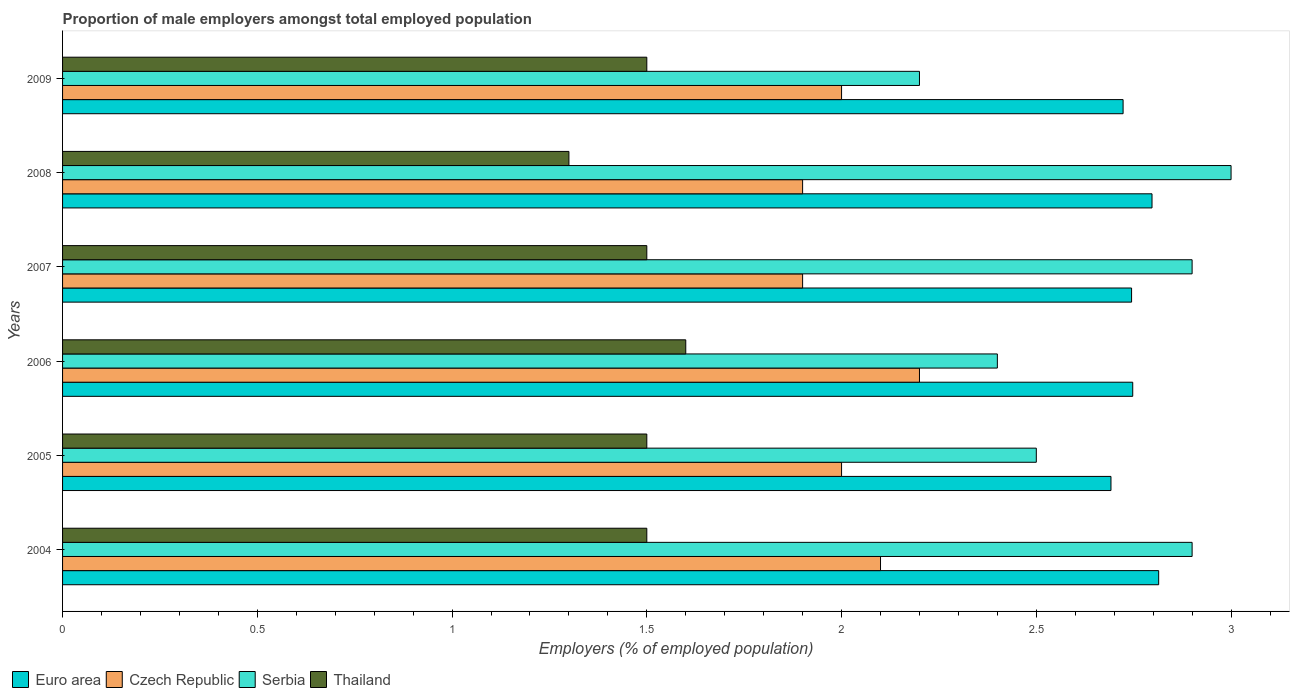How many different coloured bars are there?
Keep it short and to the point. 4. How many groups of bars are there?
Keep it short and to the point. 6. Are the number of bars per tick equal to the number of legend labels?
Offer a terse response. Yes. How many bars are there on the 4th tick from the top?
Ensure brevity in your answer.  4. What is the label of the 4th group of bars from the top?
Offer a very short reply. 2006. In how many cases, is the number of bars for a given year not equal to the number of legend labels?
Ensure brevity in your answer.  0. What is the proportion of male employers in Serbia in 2007?
Ensure brevity in your answer.  2.9. Across all years, what is the maximum proportion of male employers in Czech Republic?
Provide a succinct answer. 2.2. Across all years, what is the minimum proportion of male employers in Serbia?
Provide a succinct answer. 2.2. In which year was the proportion of male employers in Czech Republic maximum?
Make the answer very short. 2006. In which year was the proportion of male employers in Czech Republic minimum?
Keep it short and to the point. 2007. What is the total proportion of male employers in Euro area in the graph?
Provide a succinct answer. 16.52. What is the difference between the proportion of male employers in Serbia in 2006 and that in 2007?
Keep it short and to the point. -0.5. What is the difference between the proportion of male employers in Serbia in 2004 and the proportion of male employers in Thailand in 2008?
Give a very brief answer. 1.6. What is the average proportion of male employers in Czech Republic per year?
Offer a very short reply. 2.02. In the year 2008, what is the difference between the proportion of male employers in Thailand and proportion of male employers in Czech Republic?
Your response must be concise. -0.6. In how many years, is the proportion of male employers in Euro area greater than 2.7 %?
Provide a short and direct response. 5. What is the ratio of the proportion of male employers in Euro area in 2005 to that in 2007?
Keep it short and to the point. 0.98. What is the difference between the highest and the second highest proportion of male employers in Euro area?
Offer a very short reply. 0.02. What is the difference between the highest and the lowest proportion of male employers in Thailand?
Your answer should be very brief. 0.3. In how many years, is the proportion of male employers in Serbia greater than the average proportion of male employers in Serbia taken over all years?
Keep it short and to the point. 3. Is the sum of the proportion of male employers in Czech Republic in 2004 and 2009 greater than the maximum proportion of male employers in Serbia across all years?
Offer a very short reply. Yes. Is it the case that in every year, the sum of the proportion of male employers in Czech Republic and proportion of male employers in Euro area is greater than the sum of proportion of male employers in Serbia and proportion of male employers in Thailand?
Your response must be concise. Yes. What does the 3rd bar from the top in 2009 represents?
Keep it short and to the point. Czech Republic. What does the 3rd bar from the bottom in 2006 represents?
Your answer should be very brief. Serbia. How many bars are there?
Your response must be concise. 24. How many years are there in the graph?
Keep it short and to the point. 6. Does the graph contain any zero values?
Your answer should be very brief. No. Where does the legend appear in the graph?
Offer a very short reply. Bottom left. How are the legend labels stacked?
Provide a succinct answer. Horizontal. What is the title of the graph?
Provide a succinct answer. Proportion of male employers amongst total employed population. Does "High income" appear as one of the legend labels in the graph?
Offer a terse response. No. What is the label or title of the X-axis?
Provide a short and direct response. Employers (% of employed population). What is the label or title of the Y-axis?
Ensure brevity in your answer.  Years. What is the Employers (% of employed population) in Euro area in 2004?
Your response must be concise. 2.81. What is the Employers (% of employed population) of Czech Republic in 2004?
Your answer should be very brief. 2.1. What is the Employers (% of employed population) of Serbia in 2004?
Your answer should be very brief. 2.9. What is the Employers (% of employed population) in Thailand in 2004?
Provide a succinct answer. 1.5. What is the Employers (% of employed population) in Euro area in 2005?
Your response must be concise. 2.69. What is the Employers (% of employed population) in Czech Republic in 2005?
Keep it short and to the point. 2. What is the Employers (% of employed population) in Thailand in 2005?
Ensure brevity in your answer.  1.5. What is the Employers (% of employed population) of Euro area in 2006?
Make the answer very short. 2.75. What is the Employers (% of employed population) in Czech Republic in 2006?
Your response must be concise. 2.2. What is the Employers (% of employed population) of Serbia in 2006?
Your response must be concise. 2.4. What is the Employers (% of employed population) in Thailand in 2006?
Make the answer very short. 1.6. What is the Employers (% of employed population) of Euro area in 2007?
Ensure brevity in your answer.  2.74. What is the Employers (% of employed population) of Czech Republic in 2007?
Your answer should be compact. 1.9. What is the Employers (% of employed population) in Serbia in 2007?
Provide a short and direct response. 2.9. What is the Employers (% of employed population) of Thailand in 2007?
Your answer should be compact. 1.5. What is the Employers (% of employed population) in Euro area in 2008?
Your answer should be compact. 2.8. What is the Employers (% of employed population) in Czech Republic in 2008?
Offer a terse response. 1.9. What is the Employers (% of employed population) of Thailand in 2008?
Your answer should be very brief. 1.3. What is the Employers (% of employed population) of Euro area in 2009?
Provide a succinct answer. 2.72. What is the Employers (% of employed population) of Serbia in 2009?
Keep it short and to the point. 2.2. What is the Employers (% of employed population) in Thailand in 2009?
Offer a terse response. 1.5. Across all years, what is the maximum Employers (% of employed population) in Euro area?
Provide a short and direct response. 2.81. Across all years, what is the maximum Employers (% of employed population) in Czech Republic?
Offer a terse response. 2.2. Across all years, what is the maximum Employers (% of employed population) in Serbia?
Your answer should be very brief. 3. Across all years, what is the maximum Employers (% of employed population) of Thailand?
Give a very brief answer. 1.6. Across all years, what is the minimum Employers (% of employed population) of Euro area?
Provide a succinct answer. 2.69. Across all years, what is the minimum Employers (% of employed population) in Czech Republic?
Provide a short and direct response. 1.9. Across all years, what is the minimum Employers (% of employed population) of Serbia?
Your answer should be compact. 2.2. Across all years, what is the minimum Employers (% of employed population) in Thailand?
Provide a short and direct response. 1.3. What is the total Employers (% of employed population) in Euro area in the graph?
Your response must be concise. 16.52. What is the total Employers (% of employed population) of Serbia in the graph?
Provide a succinct answer. 15.9. What is the difference between the Employers (% of employed population) in Euro area in 2004 and that in 2005?
Ensure brevity in your answer.  0.12. What is the difference between the Employers (% of employed population) of Thailand in 2004 and that in 2005?
Offer a terse response. 0. What is the difference between the Employers (% of employed population) of Euro area in 2004 and that in 2006?
Make the answer very short. 0.07. What is the difference between the Employers (% of employed population) of Serbia in 2004 and that in 2006?
Your answer should be compact. 0.5. What is the difference between the Employers (% of employed population) of Euro area in 2004 and that in 2007?
Your response must be concise. 0.07. What is the difference between the Employers (% of employed population) in Thailand in 2004 and that in 2007?
Give a very brief answer. 0. What is the difference between the Employers (% of employed population) in Euro area in 2004 and that in 2008?
Provide a succinct answer. 0.02. What is the difference between the Employers (% of employed population) in Czech Republic in 2004 and that in 2008?
Provide a short and direct response. 0.2. What is the difference between the Employers (% of employed population) of Serbia in 2004 and that in 2008?
Offer a very short reply. -0.1. What is the difference between the Employers (% of employed population) in Euro area in 2004 and that in 2009?
Give a very brief answer. 0.09. What is the difference between the Employers (% of employed population) of Czech Republic in 2004 and that in 2009?
Offer a terse response. 0.1. What is the difference between the Employers (% of employed population) of Serbia in 2004 and that in 2009?
Your answer should be compact. 0.7. What is the difference between the Employers (% of employed population) in Thailand in 2004 and that in 2009?
Provide a short and direct response. 0. What is the difference between the Employers (% of employed population) of Euro area in 2005 and that in 2006?
Provide a short and direct response. -0.06. What is the difference between the Employers (% of employed population) of Serbia in 2005 and that in 2006?
Your answer should be very brief. 0.1. What is the difference between the Employers (% of employed population) of Thailand in 2005 and that in 2006?
Ensure brevity in your answer.  -0.1. What is the difference between the Employers (% of employed population) in Euro area in 2005 and that in 2007?
Offer a very short reply. -0.05. What is the difference between the Employers (% of employed population) in Czech Republic in 2005 and that in 2007?
Provide a short and direct response. 0.1. What is the difference between the Employers (% of employed population) in Thailand in 2005 and that in 2007?
Keep it short and to the point. 0. What is the difference between the Employers (% of employed population) in Euro area in 2005 and that in 2008?
Your response must be concise. -0.11. What is the difference between the Employers (% of employed population) of Czech Republic in 2005 and that in 2008?
Ensure brevity in your answer.  0.1. What is the difference between the Employers (% of employed population) in Thailand in 2005 and that in 2008?
Offer a terse response. 0.2. What is the difference between the Employers (% of employed population) of Euro area in 2005 and that in 2009?
Your answer should be very brief. -0.03. What is the difference between the Employers (% of employed population) of Czech Republic in 2005 and that in 2009?
Offer a terse response. 0. What is the difference between the Employers (% of employed population) of Serbia in 2005 and that in 2009?
Make the answer very short. 0.3. What is the difference between the Employers (% of employed population) in Thailand in 2005 and that in 2009?
Your response must be concise. 0. What is the difference between the Employers (% of employed population) in Euro area in 2006 and that in 2007?
Your answer should be compact. 0. What is the difference between the Employers (% of employed population) of Euro area in 2006 and that in 2008?
Ensure brevity in your answer.  -0.05. What is the difference between the Employers (% of employed population) in Czech Republic in 2006 and that in 2008?
Your answer should be very brief. 0.3. What is the difference between the Employers (% of employed population) of Euro area in 2006 and that in 2009?
Your answer should be very brief. 0.02. What is the difference between the Employers (% of employed population) of Serbia in 2006 and that in 2009?
Offer a very short reply. 0.2. What is the difference between the Employers (% of employed population) in Thailand in 2006 and that in 2009?
Provide a short and direct response. 0.1. What is the difference between the Employers (% of employed population) of Euro area in 2007 and that in 2008?
Your answer should be compact. -0.05. What is the difference between the Employers (% of employed population) in Euro area in 2007 and that in 2009?
Your answer should be compact. 0.02. What is the difference between the Employers (% of employed population) in Serbia in 2007 and that in 2009?
Offer a very short reply. 0.7. What is the difference between the Employers (% of employed population) of Euro area in 2008 and that in 2009?
Your answer should be compact. 0.07. What is the difference between the Employers (% of employed population) of Czech Republic in 2008 and that in 2009?
Offer a very short reply. -0.1. What is the difference between the Employers (% of employed population) of Serbia in 2008 and that in 2009?
Offer a terse response. 0.8. What is the difference between the Employers (% of employed population) in Euro area in 2004 and the Employers (% of employed population) in Czech Republic in 2005?
Your answer should be very brief. 0.81. What is the difference between the Employers (% of employed population) in Euro area in 2004 and the Employers (% of employed population) in Serbia in 2005?
Offer a terse response. 0.31. What is the difference between the Employers (% of employed population) of Euro area in 2004 and the Employers (% of employed population) of Thailand in 2005?
Make the answer very short. 1.31. What is the difference between the Employers (% of employed population) of Czech Republic in 2004 and the Employers (% of employed population) of Serbia in 2005?
Provide a succinct answer. -0.4. What is the difference between the Employers (% of employed population) of Czech Republic in 2004 and the Employers (% of employed population) of Thailand in 2005?
Your answer should be compact. 0.6. What is the difference between the Employers (% of employed population) of Serbia in 2004 and the Employers (% of employed population) of Thailand in 2005?
Give a very brief answer. 1.4. What is the difference between the Employers (% of employed population) of Euro area in 2004 and the Employers (% of employed population) of Czech Republic in 2006?
Your response must be concise. 0.61. What is the difference between the Employers (% of employed population) of Euro area in 2004 and the Employers (% of employed population) of Serbia in 2006?
Offer a very short reply. 0.41. What is the difference between the Employers (% of employed population) of Euro area in 2004 and the Employers (% of employed population) of Thailand in 2006?
Your answer should be very brief. 1.21. What is the difference between the Employers (% of employed population) of Serbia in 2004 and the Employers (% of employed population) of Thailand in 2006?
Provide a short and direct response. 1.3. What is the difference between the Employers (% of employed population) in Euro area in 2004 and the Employers (% of employed population) in Czech Republic in 2007?
Your answer should be very brief. 0.91. What is the difference between the Employers (% of employed population) of Euro area in 2004 and the Employers (% of employed population) of Serbia in 2007?
Offer a terse response. -0.09. What is the difference between the Employers (% of employed population) of Euro area in 2004 and the Employers (% of employed population) of Thailand in 2007?
Keep it short and to the point. 1.31. What is the difference between the Employers (% of employed population) of Czech Republic in 2004 and the Employers (% of employed population) of Thailand in 2007?
Your answer should be compact. 0.6. What is the difference between the Employers (% of employed population) in Euro area in 2004 and the Employers (% of employed population) in Czech Republic in 2008?
Your answer should be compact. 0.91. What is the difference between the Employers (% of employed population) in Euro area in 2004 and the Employers (% of employed population) in Serbia in 2008?
Offer a terse response. -0.19. What is the difference between the Employers (% of employed population) in Euro area in 2004 and the Employers (% of employed population) in Thailand in 2008?
Make the answer very short. 1.51. What is the difference between the Employers (% of employed population) in Czech Republic in 2004 and the Employers (% of employed population) in Serbia in 2008?
Offer a terse response. -0.9. What is the difference between the Employers (% of employed population) of Euro area in 2004 and the Employers (% of employed population) of Czech Republic in 2009?
Provide a succinct answer. 0.81. What is the difference between the Employers (% of employed population) in Euro area in 2004 and the Employers (% of employed population) in Serbia in 2009?
Your answer should be very brief. 0.61. What is the difference between the Employers (% of employed population) of Euro area in 2004 and the Employers (% of employed population) of Thailand in 2009?
Your response must be concise. 1.31. What is the difference between the Employers (% of employed population) in Czech Republic in 2004 and the Employers (% of employed population) in Serbia in 2009?
Your answer should be compact. -0.1. What is the difference between the Employers (% of employed population) of Czech Republic in 2004 and the Employers (% of employed population) of Thailand in 2009?
Offer a terse response. 0.6. What is the difference between the Employers (% of employed population) in Euro area in 2005 and the Employers (% of employed population) in Czech Republic in 2006?
Make the answer very short. 0.49. What is the difference between the Employers (% of employed population) in Euro area in 2005 and the Employers (% of employed population) in Serbia in 2006?
Your response must be concise. 0.29. What is the difference between the Employers (% of employed population) in Euro area in 2005 and the Employers (% of employed population) in Thailand in 2006?
Offer a very short reply. 1.09. What is the difference between the Employers (% of employed population) of Czech Republic in 2005 and the Employers (% of employed population) of Thailand in 2006?
Keep it short and to the point. 0.4. What is the difference between the Employers (% of employed population) in Serbia in 2005 and the Employers (% of employed population) in Thailand in 2006?
Keep it short and to the point. 0.9. What is the difference between the Employers (% of employed population) in Euro area in 2005 and the Employers (% of employed population) in Czech Republic in 2007?
Ensure brevity in your answer.  0.79. What is the difference between the Employers (% of employed population) of Euro area in 2005 and the Employers (% of employed population) of Serbia in 2007?
Make the answer very short. -0.21. What is the difference between the Employers (% of employed population) in Euro area in 2005 and the Employers (% of employed population) in Thailand in 2007?
Your response must be concise. 1.19. What is the difference between the Employers (% of employed population) of Czech Republic in 2005 and the Employers (% of employed population) of Serbia in 2007?
Your answer should be very brief. -0.9. What is the difference between the Employers (% of employed population) in Czech Republic in 2005 and the Employers (% of employed population) in Thailand in 2007?
Give a very brief answer. 0.5. What is the difference between the Employers (% of employed population) in Serbia in 2005 and the Employers (% of employed population) in Thailand in 2007?
Your answer should be compact. 1. What is the difference between the Employers (% of employed population) in Euro area in 2005 and the Employers (% of employed population) in Czech Republic in 2008?
Your answer should be compact. 0.79. What is the difference between the Employers (% of employed population) of Euro area in 2005 and the Employers (% of employed population) of Serbia in 2008?
Ensure brevity in your answer.  -0.31. What is the difference between the Employers (% of employed population) of Euro area in 2005 and the Employers (% of employed population) of Thailand in 2008?
Your answer should be compact. 1.39. What is the difference between the Employers (% of employed population) in Czech Republic in 2005 and the Employers (% of employed population) in Serbia in 2008?
Provide a short and direct response. -1. What is the difference between the Employers (% of employed population) of Czech Republic in 2005 and the Employers (% of employed population) of Thailand in 2008?
Your answer should be very brief. 0.7. What is the difference between the Employers (% of employed population) of Serbia in 2005 and the Employers (% of employed population) of Thailand in 2008?
Provide a short and direct response. 1.2. What is the difference between the Employers (% of employed population) of Euro area in 2005 and the Employers (% of employed population) of Czech Republic in 2009?
Your response must be concise. 0.69. What is the difference between the Employers (% of employed population) in Euro area in 2005 and the Employers (% of employed population) in Serbia in 2009?
Offer a very short reply. 0.49. What is the difference between the Employers (% of employed population) of Euro area in 2005 and the Employers (% of employed population) of Thailand in 2009?
Offer a terse response. 1.19. What is the difference between the Employers (% of employed population) in Czech Republic in 2005 and the Employers (% of employed population) in Serbia in 2009?
Make the answer very short. -0.2. What is the difference between the Employers (% of employed population) of Serbia in 2005 and the Employers (% of employed population) of Thailand in 2009?
Give a very brief answer. 1. What is the difference between the Employers (% of employed population) of Euro area in 2006 and the Employers (% of employed population) of Czech Republic in 2007?
Ensure brevity in your answer.  0.85. What is the difference between the Employers (% of employed population) of Euro area in 2006 and the Employers (% of employed population) of Serbia in 2007?
Make the answer very short. -0.15. What is the difference between the Employers (% of employed population) of Euro area in 2006 and the Employers (% of employed population) of Thailand in 2007?
Your answer should be very brief. 1.25. What is the difference between the Employers (% of employed population) of Czech Republic in 2006 and the Employers (% of employed population) of Serbia in 2007?
Offer a terse response. -0.7. What is the difference between the Employers (% of employed population) of Czech Republic in 2006 and the Employers (% of employed population) of Thailand in 2007?
Offer a very short reply. 0.7. What is the difference between the Employers (% of employed population) in Euro area in 2006 and the Employers (% of employed population) in Czech Republic in 2008?
Keep it short and to the point. 0.85. What is the difference between the Employers (% of employed population) of Euro area in 2006 and the Employers (% of employed population) of Serbia in 2008?
Offer a very short reply. -0.25. What is the difference between the Employers (% of employed population) of Euro area in 2006 and the Employers (% of employed population) of Thailand in 2008?
Keep it short and to the point. 1.45. What is the difference between the Employers (% of employed population) in Czech Republic in 2006 and the Employers (% of employed population) in Serbia in 2008?
Your response must be concise. -0.8. What is the difference between the Employers (% of employed population) of Czech Republic in 2006 and the Employers (% of employed population) of Thailand in 2008?
Offer a terse response. 0.9. What is the difference between the Employers (% of employed population) of Serbia in 2006 and the Employers (% of employed population) of Thailand in 2008?
Your answer should be compact. 1.1. What is the difference between the Employers (% of employed population) of Euro area in 2006 and the Employers (% of employed population) of Czech Republic in 2009?
Ensure brevity in your answer.  0.75. What is the difference between the Employers (% of employed population) in Euro area in 2006 and the Employers (% of employed population) in Serbia in 2009?
Your answer should be compact. 0.55. What is the difference between the Employers (% of employed population) of Euro area in 2006 and the Employers (% of employed population) of Thailand in 2009?
Offer a very short reply. 1.25. What is the difference between the Employers (% of employed population) in Czech Republic in 2006 and the Employers (% of employed population) in Thailand in 2009?
Your answer should be compact. 0.7. What is the difference between the Employers (% of employed population) in Serbia in 2006 and the Employers (% of employed population) in Thailand in 2009?
Your response must be concise. 0.9. What is the difference between the Employers (% of employed population) in Euro area in 2007 and the Employers (% of employed population) in Czech Republic in 2008?
Your answer should be very brief. 0.84. What is the difference between the Employers (% of employed population) of Euro area in 2007 and the Employers (% of employed population) of Serbia in 2008?
Provide a succinct answer. -0.26. What is the difference between the Employers (% of employed population) in Euro area in 2007 and the Employers (% of employed population) in Thailand in 2008?
Offer a very short reply. 1.44. What is the difference between the Employers (% of employed population) of Euro area in 2007 and the Employers (% of employed population) of Czech Republic in 2009?
Your response must be concise. 0.74. What is the difference between the Employers (% of employed population) of Euro area in 2007 and the Employers (% of employed population) of Serbia in 2009?
Your answer should be very brief. 0.54. What is the difference between the Employers (% of employed population) in Euro area in 2007 and the Employers (% of employed population) in Thailand in 2009?
Provide a succinct answer. 1.24. What is the difference between the Employers (% of employed population) of Czech Republic in 2007 and the Employers (% of employed population) of Serbia in 2009?
Keep it short and to the point. -0.3. What is the difference between the Employers (% of employed population) of Czech Republic in 2007 and the Employers (% of employed population) of Thailand in 2009?
Provide a succinct answer. 0.4. What is the difference between the Employers (% of employed population) in Euro area in 2008 and the Employers (% of employed population) in Czech Republic in 2009?
Offer a terse response. 0.8. What is the difference between the Employers (% of employed population) in Euro area in 2008 and the Employers (% of employed population) in Serbia in 2009?
Offer a terse response. 0.6. What is the difference between the Employers (% of employed population) of Euro area in 2008 and the Employers (% of employed population) of Thailand in 2009?
Give a very brief answer. 1.3. What is the difference between the Employers (% of employed population) of Czech Republic in 2008 and the Employers (% of employed population) of Thailand in 2009?
Your answer should be compact. 0.4. What is the difference between the Employers (% of employed population) in Serbia in 2008 and the Employers (% of employed population) in Thailand in 2009?
Provide a succinct answer. 1.5. What is the average Employers (% of employed population) of Euro area per year?
Provide a short and direct response. 2.75. What is the average Employers (% of employed population) in Czech Republic per year?
Your answer should be very brief. 2.02. What is the average Employers (% of employed population) of Serbia per year?
Offer a very short reply. 2.65. What is the average Employers (% of employed population) of Thailand per year?
Provide a short and direct response. 1.48. In the year 2004, what is the difference between the Employers (% of employed population) of Euro area and Employers (% of employed population) of Czech Republic?
Provide a succinct answer. 0.71. In the year 2004, what is the difference between the Employers (% of employed population) in Euro area and Employers (% of employed population) in Serbia?
Your answer should be very brief. -0.09. In the year 2004, what is the difference between the Employers (% of employed population) of Euro area and Employers (% of employed population) of Thailand?
Provide a short and direct response. 1.31. In the year 2004, what is the difference between the Employers (% of employed population) of Czech Republic and Employers (% of employed population) of Serbia?
Your answer should be very brief. -0.8. In the year 2005, what is the difference between the Employers (% of employed population) of Euro area and Employers (% of employed population) of Czech Republic?
Your response must be concise. 0.69. In the year 2005, what is the difference between the Employers (% of employed population) of Euro area and Employers (% of employed population) of Serbia?
Your answer should be compact. 0.19. In the year 2005, what is the difference between the Employers (% of employed population) of Euro area and Employers (% of employed population) of Thailand?
Give a very brief answer. 1.19. In the year 2005, what is the difference between the Employers (% of employed population) in Czech Republic and Employers (% of employed population) in Serbia?
Give a very brief answer. -0.5. In the year 2005, what is the difference between the Employers (% of employed population) of Czech Republic and Employers (% of employed population) of Thailand?
Provide a succinct answer. 0.5. In the year 2006, what is the difference between the Employers (% of employed population) of Euro area and Employers (% of employed population) of Czech Republic?
Your answer should be very brief. 0.55. In the year 2006, what is the difference between the Employers (% of employed population) of Euro area and Employers (% of employed population) of Serbia?
Your response must be concise. 0.35. In the year 2006, what is the difference between the Employers (% of employed population) in Euro area and Employers (% of employed population) in Thailand?
Your answer should be very brief. 1.15. In the year 2006, what is the difference between the Employers (% of employed population) of Czech Republic and Employers (% of employed population) of Thailand?
Keep it short and to the point. 0.6. In the year 2007, what is the difference between the Employers (% of employed population) in Euro area and Employers (% of employed population) in Czech Republic?
Provide a succinct answer. 0.84. In the year 2007, what is the difference between the Employers (% of employed population) of Euro area and Employers (% of employed population) of Serbia?
Offer a terse response. -0.16. In the year 2007, what is the difference between the Employers (% of employed population) of Euro area and Employers (% of employed population) of Thailand?
Keep it short and to the point. 1.24. In the year 2007, what is the difference between the Employers (% of employed population) in Czech Republic and Employers (% of employed population) in Thailand?
Make the answer very short. 0.4. In the year 2008, what is the difference between the Employers (% of employed population) of Euro area and Employers (% of employed population) of Czech Republic?
Offer a very short reply. 0.9. In the year 2008, what is the difference between the Employers (% of employed population) of Euro area and Employers (% of employed population) of Serbia?
Keep it short and to the point. -0.2. In the year 2008, what is the difference between the Employers (% of employed population) in Euro area and Employers (% of employed population) in Thailand?
Your answer should be very brief. 1.5. In the year 2008, what is the difference between the Employers (% of employed population) in Czech Republic and Employers (% of employed population) in Serbia?
Your answer should be very brief. -1.1. In the year 2008, what is the difference between the Employers (% of employed population) in Serbia and Employers (% of employed population) in Thailand?
Make the answer very short. 1.7. In the year 2009, what is the difference between the Employers (% of employed population) of Euro area and Employers (% of employed population) of Czech Republic?
Your response must be concise. 0.72. In the year 2009, what is the difference between the Employers (% of employed population) in Euro area and Employers (% of employed population) in Serbia?
Provide a succinct answer. 0.52. In the year 2009, what is the difference between the Employers (% of employed population) in Euro area and Employers (% of employed population) in Thailand?
Offer a very short reply. 1.22. In the year 2009, what is the difference between the Employers (% of employed population) of Czech Republic and Employers (% of employed population) of Serbia?
Your answer should be compact. -0.2. In the year 2009, what is the difference between the Employers (% of employed population) in Czech Republic and Employers (% of employed population) in Thailand?
Provide a succinct answer. 0.5. In the year 2009, what is the difference between the Employers (% of employed population) in Serbia and Employers (% of employed population) in Thailand?
Your answer should be very brief. 0.7. What is the ratio of the Employers (% of employed population) in Euro area in 2004 to that in 2005?
Ensure brevity in your answer.  1.05. What is the ratio of the Employers (% of employed population) of Czech Republic in 2004 to that in 2005?
Give a very brief answer. 1.05. What is the ratio of the Employers (% of employed population) of Serbia in 2004 to that in 2005?
Provide a succinct answer. 1.16. What is the ratio of the Employers (% of employed population) in Euro area in 2004 to that in 2006?
Offer a very short reply. 1.02. What is the ratio of the Employers (% of employed population) in Czech Republic in 2004 to that in 2006?
Keep it short and to the point. 0.95. What is the ratio of the Employers (% of employed population) in Serbia in 2004 to that in 2006?
Keep it short and to the point. 1.21. What is the ratio of the Employers (% of employed population) of Thailand in 2004 to that in 2006?
Keep it short and to the point. 0.94. What is the ratio of the Employers (% of employed population) of Euro area in 2004 to that in 2007?
Provide a succinct answer. 1.03. What is the ratio of the Employers (% of employed population) of Czech Republic in 2004 to that in 2007?
Make the answer very short. 1.11. What is the ratio of the Employers (% of employed population) in Thailand in 2004 to that in 2007?
Offer a very short reply. 1. What is the ratio of the Employers (% of employed population) in Czech Republic in 2004 to that in 2008?
Keep it short and to the point. 1.11. What is the ratio of the Employers (% of employed population) in Serbia in 2004 to that in 2008?
Give a very brief answer. 0.97. What is the ratio of the Employers (% of employed population) in Thailand in 2004 to that in 2008?
Offer a terse response. 1.15. What is the ratio of the Employers (% of employed population) of Euro area in 2004 to that in 2009?
Offer a terse response. 1.03. What is the ratio of the Employers (% of employed population) of Serbia in 2004 to that in 2009?
Give a very brief answer. 1.32. What is the ratio of the Employers (% of employed population) in Euro area in 2005 to that in 2006?
Keep it short and to the point. 0.98. What is the ratio of the Employers (% of employed population) of Czech Republic in 2005 to that in 2006?
Make the answer very short. 0.91. What is the ratio of the Employers (% of employed population) in Serbia in 2005 to that in 2006?
Keep it short and to the point. 1.04. What is the ratio of the Employers (% of employed population) in Euro area in 2005 to that in 2007?
Ensure brevity in your answer.  0.98. What is the ratio of the Employers (% of employed population) in Czech Republic in 2005 to that in 2007?
Give a very brief answer. 1.05. What is the ratio of the Employers (% of employed population) in Serbia in 2005 to that in 2007?
Your answer should be very brief. 0.86. What is the ratio of the Employers (% of employed population) of Thailand in 2005 to that in 2007?
Offer a very short reply. 1. What is the ratio of the Employers (% of employed population) in Euro area in 2005 to that in 2008?
Your answer should be compact. 0.96. What is the ratio of the Employers (% of employed population) of Czech Republic in 2005 to that in 2008?
Offer a very short reply. 1.05. What is the ratio of the Employers (% of employed population) of Serbia in 2005 to that in 2008?
Offer a terse response. 0.83. What is the ratio of the Employers (% of employed population) of Thailand in 2005 to that in 2008?
Give a very brief answer. 1.15. What is the ratio of the Employers (% of employed population) of Euro area in 2005 to that in 2009?
Give a very brief answer. 0.99. What is the ratio of the Employers (% of employed population) of Czech Republic in 2005 to that in 2009?
Provide a succinct answer. 1. What is the ratio of the Employers (% of employed population) of Serbia in 2005 to that in 2009?
Your answer should be compact. 1.14. What is the ratio of the Employers (% of employed population) of Czech Republic in 2006 to that in 2007?
Give a very brief answer. 1.16. What is the ratio of the Employers (% of employed population) in Serbia in 2006 to that in 2007?
Your response must be concise. 0.83. What is the ratio of the Employers (% of employed population) of Thailand in 2006 to that in 2007?
Keep it short and to the point. 1.07. What is the ratio of the Employers (% of employed population) of Euro area in 2006 to that in 2008?
Keep it short and to the point. 0.98. What is the ratio of the Employers (% of employed population) of Czech Republic in 2006 to that in 2008?
Offer a terse response. 1.16. What is the ratio of the Employers (% of employed population) of Serbia in 2006 to that in 2008?
Make the answer very short. 0.8. What is the ratio of the Employers (% of employed population) of Thailand in 2006 to that in 2008?
Offer a terse response. 1.23. What is the ratio of the Employers (% of employed population) of Euro area in 2006 to that in 2009?
Your answer should be compact. 1.01. What is the ratio of the Employers (% of employed population) of Serbia in 2006 to that in 2009?
Keep it short and to the point. 1.09. What is the ratio of the Employers (% of employed population) in Thailand in 2006 to that in 2009?
Give a very brief answer. 1.07. What is the ratio of the Employers (% of employed population) of Euro area in 2007 to that in 2008?
Offer a terse response. 0.98. What is the ratio of the Employers (% of employed population) in Czech Republic in 2007 to that in 2008?
Keep it short and to the point. 1. What is the ratio of the Employers (% of employed population) in Serbia in 2007 to that in 2008?
Your answer should be compact. 0.97. What is the ratio of the Employers (% of employed population) in Thailand in 2007 to that in 2008?
Offer a very short reply. 1.15. What is the ratio of the Employers (% of employed population) in Czech Republic in 2007 to that in 2009?
Provide a succinct answer. 0.95. What is the ratio of the Employers (% of employed population) in Serbia in 2007 to that in 2009?
Offer a very short reply. 1.32. What is the ratio of the Employers (% of employed population) in Thailand in 2007 to that in 2009?
Your answer should be very brief. 1. What is the ratio of the Employers (% of employed population) of Euro area in 2008 to that in 2009?
Offer a terse response. 1.03. What is the ratio of the Employers (% of employed population) of Czech Republic in 2008 to that in 2009?
Offer a terse response. 0.95. What is the ratio of the Employers (% of employed population) of Serbia in 2008 to that in 2009?
Give a very brief answer. 1.36. What is the ratio of the Employers (% of employed population) of Thailand in 2008 to that in 2009?
Offer a very short reply. 0.87. What is the difference between the highest and the second highest Employers (% of employed population) of Euro area?
Keep it short and to the point. 0.02. What is the difference between the highest and the second highest Employers (% of employed population) in Thailand?
Your response must be concise. 0.1. What is the difference between the highest and the lowest Employers (% of employed population) of Euro area?
Provide a succinct answer. 0.12. What is the difference between the highest and the lowest Employers (% of employed population) in Czech Republic?
Give a very brief answer. 0.3. What is the difference between the highest and the lowest Employers (% of employed population) in Serbia?
Make the answer very short. 0.8. 